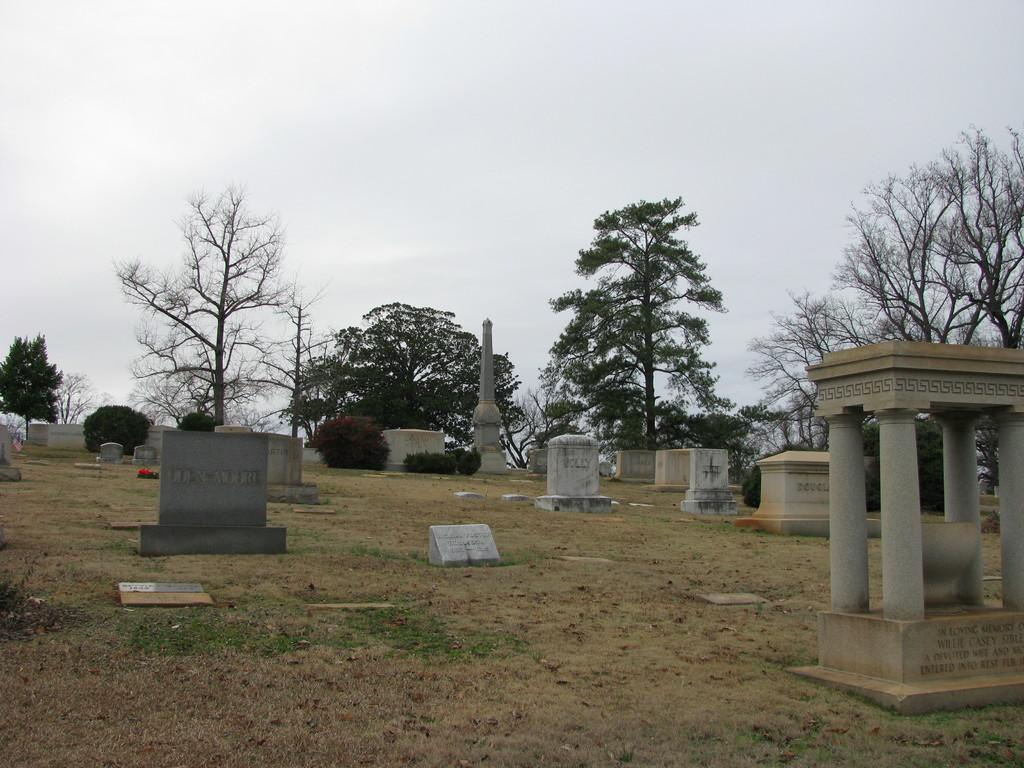What type of location is depicted in the image? There is a graveyard in the image. What is the surface of the graveyard? The graveyard is on a grass surface. What can be found within the graveyard? There are graves in the graveyard. What is visible in the background of the image? There are trees and the sky in the background of the image. How does the snow affect the pain of the person buried in the graveyard? There is no mention of snow or a person buried in the graveyard in the image, so it is not possible to answer this question. 